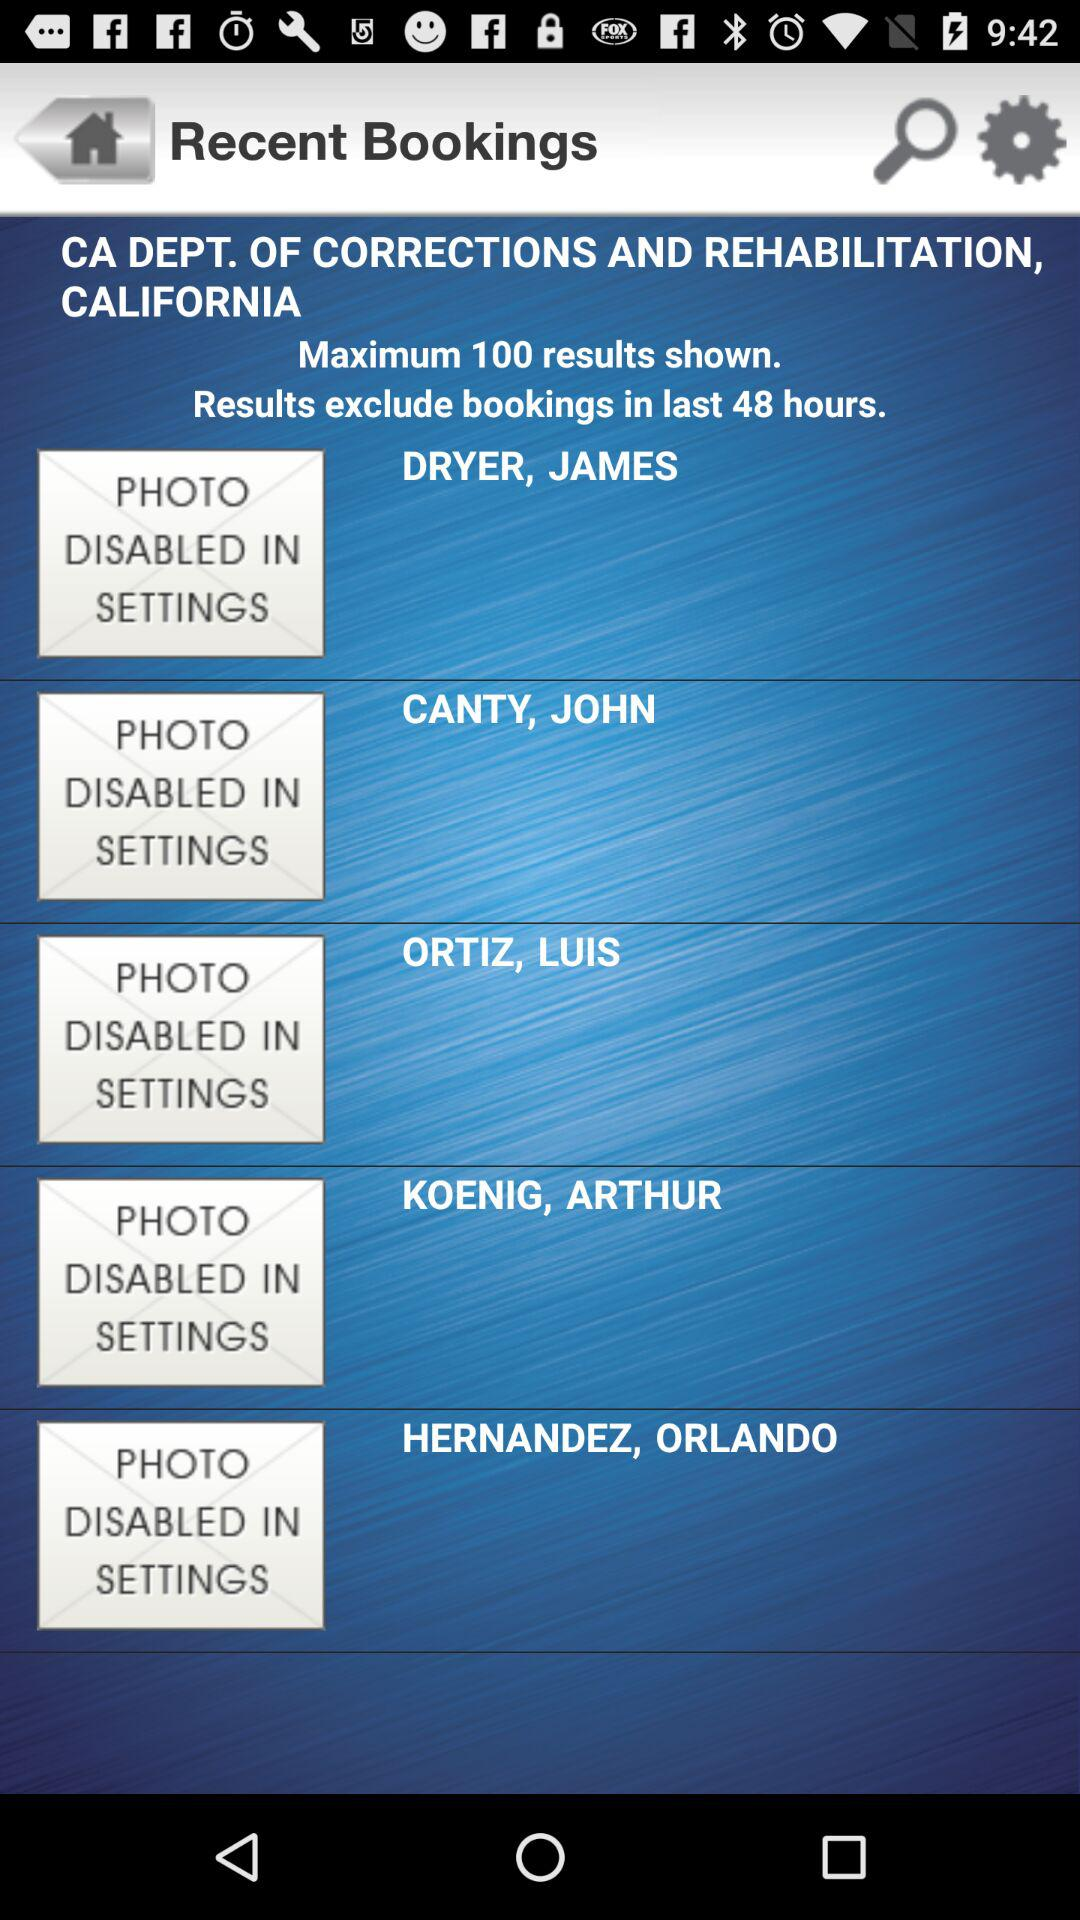How many last-hour results are excluded from bookings? Results are excluded from bookings made within the last 48 hours. 